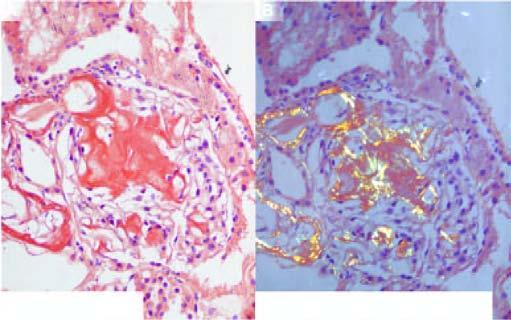did apoptosis stain red-pink congophilia?
Answer the question using a single word or phrase. No 